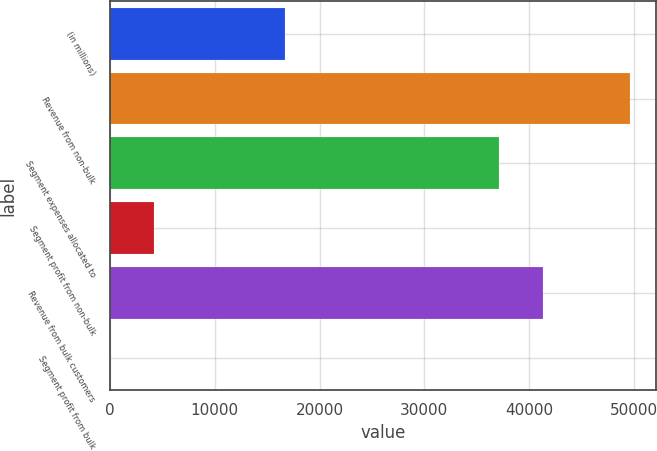<chart> <loc_0><loc_0><loc_500><loc_500><bar_chart><fcel>(in millions)<fcel>Revenue from non-bulk<fcel>Segment expenses allocated to<fcel>Segment profit from non-bulk<fcel>Revenue from bulk customers<fcel>Segment profit from bulk<nl><fcel>16700.7<fcel>49661.2<fcel>37136<fcel>4175.55<fcel>41311.1<fcel>0.5<nl></chart> 